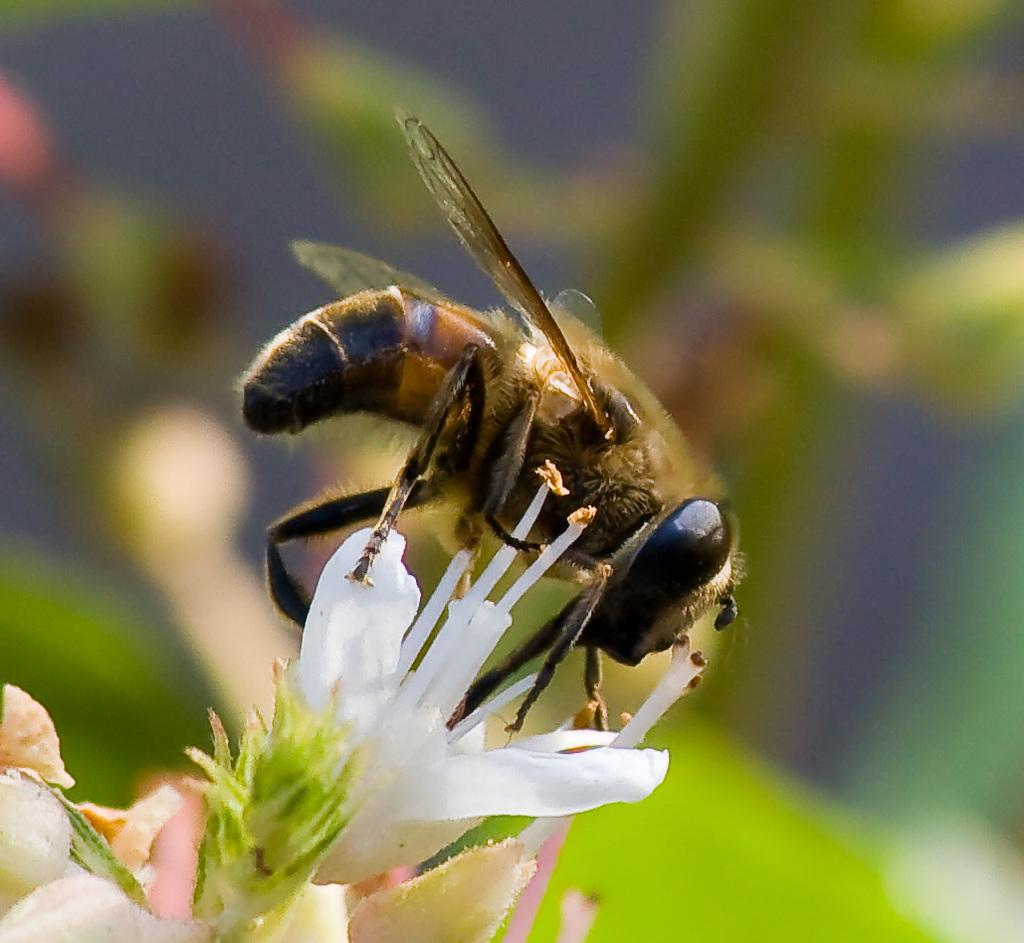What type of insect is in the image? There is a honey bee in the image. What is the honey bee doing in the image? The honey bee is on a white flower. Can you describe the background of the image? The background of the image is blurred. What action is the honey bee performing on the window in the image? There is no window present in the image, and the honey bee is on a white flower, not performing any action on a window. 